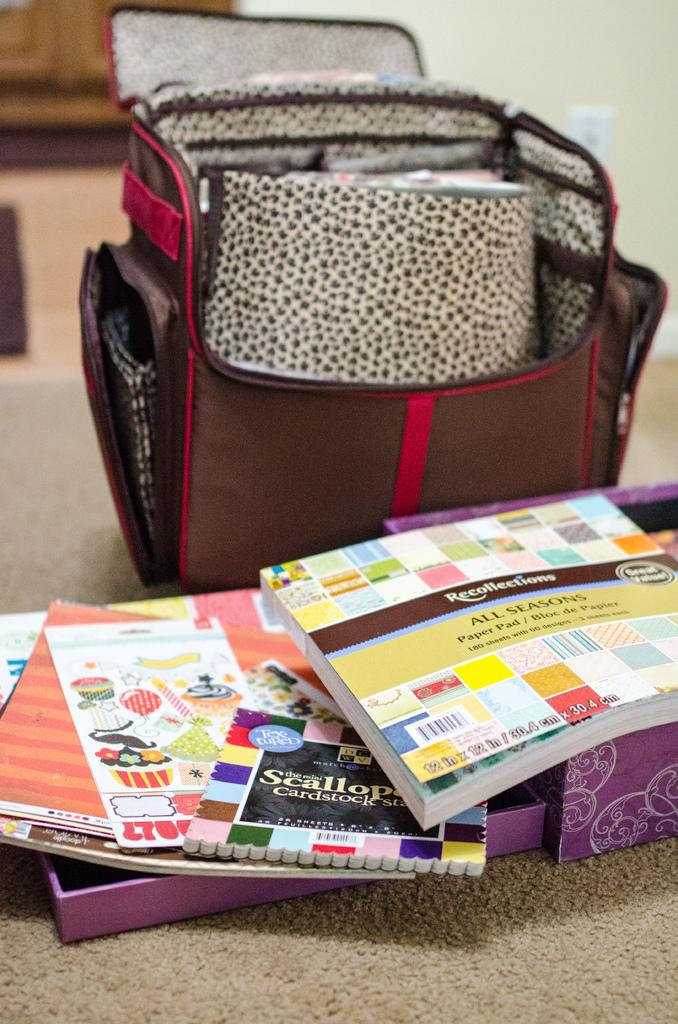What objects are in the foreground of the picture? There are books, a box, and a backpack in the foreground of the picture. What are the objects placed on? The objects are on a mat. How would you describe the background of the image? The background of the image is blurred. What scent can be detected from the books in the image? There is no information about the scent of the books in the image, as the focus is on the objects and their placement. 